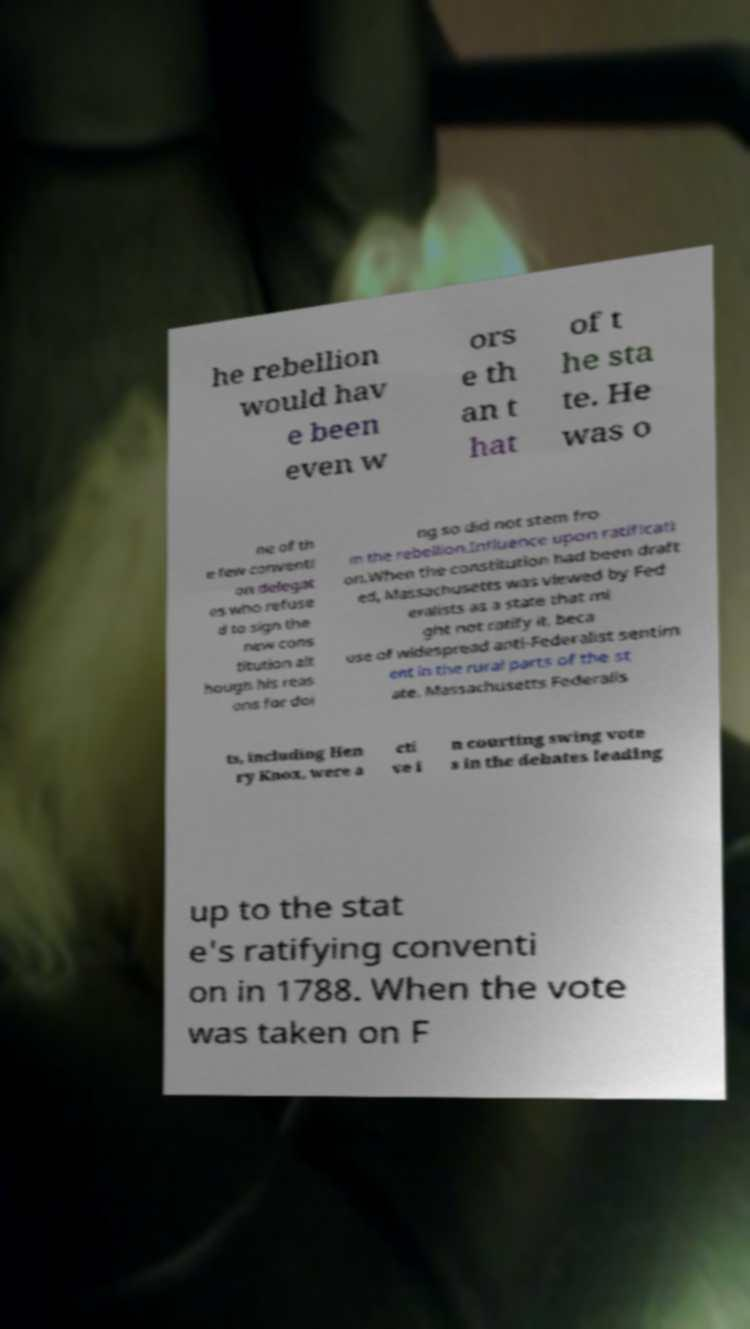Could you assist in decoding the text presented in this image and type it out clearly? he rebellion would hav e been even w ors e th an t hat of t he sta te. He was o ne of th e few conventi on delegat es who refuse d to sign the new cons titution alt hough his reas ons for doi ng so did not stem fro m the rebellion.Influence upon ratificati on.When the constitution had been draft ed, Massachusetts was viewed by Fed eralists as a state that mi ght not ratify it, beca use of widespread anti-Federalist sentim ent in the rural parts of the st ate. Massachusetts Federalis ts, including Hen ry Knox, were a cti ve i n courting swing vote s in the debates leading up to the stat e's ratifying conventi on in 1788. When the vote was taken on F 